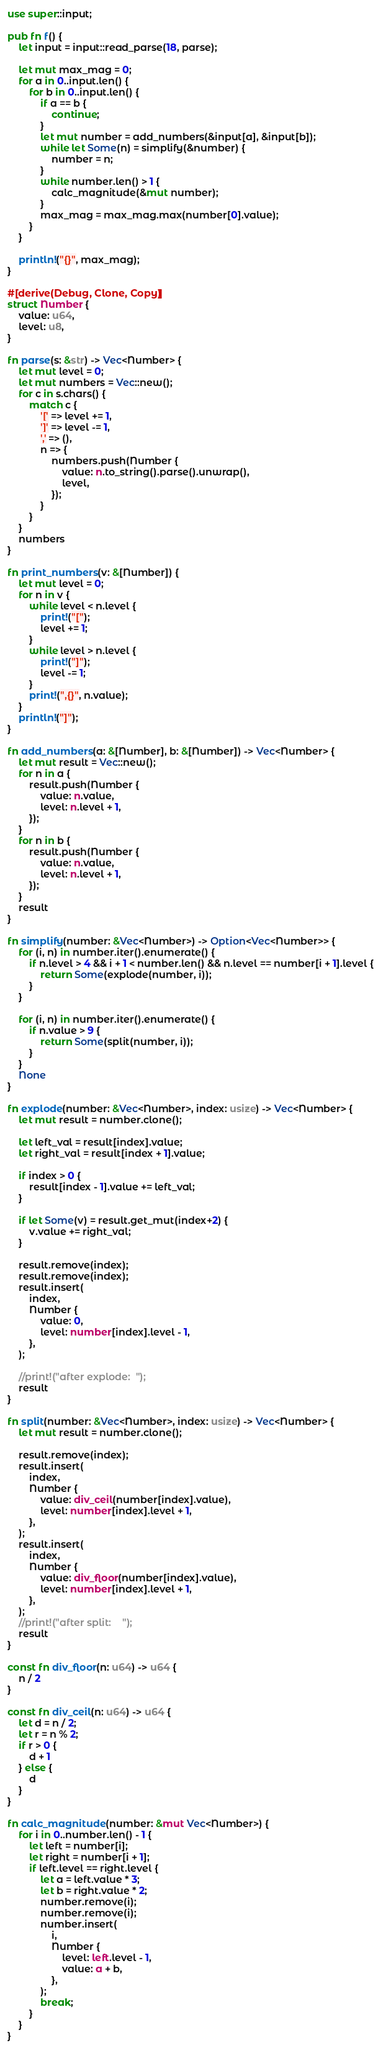Convert code to text. <code><loc_0><loc_0><loc_500><loc_500><_Rust_>use super::input;

pub fn f() {
    let input = input::read_parse(18, parse);

    let mut max_mag = 0;
    for a in 0..input.len() {
        for b in 0..input.len() {
            if a == b {
                continue;
            }
            let mut number = add_numbers(&input[a], &input[b]);
            while let Some(n) = simplify(&number) {
                number = n;
            }
            while number.len() > 1 {
                calc_magnitude(&mut number);
            }
            max_mag = max_mag.max(number[0].value);
        }
    }

    println!("{}", max_mag);
}

#[derive(Debug, Clone, Copy)]
struct Number {
    value: u64,
    level: u8,
}

fn parse(s: &str) -> Vec<Number> {
    let mut level = 0;
    let mut numbers = Vec::new();
    for c in s.chars() {
        match c {
            '[' => level += 1,
            ']' => level -= 1,
            ',' => (),
            n => {
                numbers.push(Number {
                    value: n.to_string().parse().unwrap(),
                    level,
                });
            }
        }
    }
    numbers
}

fn print_numbers(v: &[Number]) {
    let mut level = 0;
    for n in v {
        while level < n.level {
            print!("[");
            level += 1;
        }
        while level > n.level {
            print!("]");
            level -= 1;
        }
        print!(",{}", n.value);
    }
    println!("]");
}

fn add_numbers(a: &[Number], b: &[Number]) -> Vec<Number> {
    let mut result = Vec::new();
    for n in a {
        result.push(Number {
            value: n.value,
            level: n.level + 1,
        });
    }
    for n in b {
        result.push(Number {
            value: n.value,
            level: n.level + 1,
        });
    }
    result
}

fn simplify(number: &Vec<Number>) -> Option<Vec<Number>> {
    for (i, n) in number.iter().enumerate() {
        if n.level > 4 && i + 1 < number.len() && n.level == number[i + 1].level {
            return Some(explode(number, i));
        }
    }

    for (i, n) in number.iter().enumerate() {
        if n.value > 9 {
            return Some(split(number, i));
        }
    }
    None
}

fn explode(number: &Vec<Number>, index: usize) -> Vec<Number> {
    let mut result = number.clone();

    let left_val = result[index].value;
    let right_val = result[index + 1].value;

    if index > 0 {
        result[index - 1].value += left_val;
    }

    if let Some(v) = result.get_mut(index+2) {
        v.value += right_val;
    }

    result.remove(index);
    result.remove(index);
    result.insert(
        index,
        Number {
            value: 0,
            level: number[index].level - 1,
        },
    );

    //print!("after explode:  ");
    result
}

fn split(number: &Vec<Number>, index: usize) -> Vec<Number> {
    let mut result = number.clone();

    result.remove(index);
    result.insert(
        index,
        Number {
            value: div_ceil(number[index].value),
            level: number[index].level + 1,
        },
    );
    result.insert(
        index,
        Number {
            value: div_floor(number[index].value),
            level: number[index].level + 1,
        },
    );
    //print!("after split:    ");
    result
}

const fn div_floor(n: u64) -> u64 {
    n / 2
}

const fn div_ceil(n: u64) -> u64 {
    let d = n / 2;
    let r = n % 2;
    if r > 0 {
        d + 1
    } else {
        d
    }
}

fn calc_magnitude(number: &mut Vec<Number>) {
    for i in 0..number.len() - 1 {
        let left = number[i];
        let right = number[i + 1];
        if left.level == right.level {
            let a = left.value * 3;
            let b = right.value * 2;
            number.remove(i);
            number.remove(i);
            number.insert(
                i,
                Number {
                    level: left.level - 1,
                    value: a + b,
                },
            );
            break;
        }
    }
}
</code> 